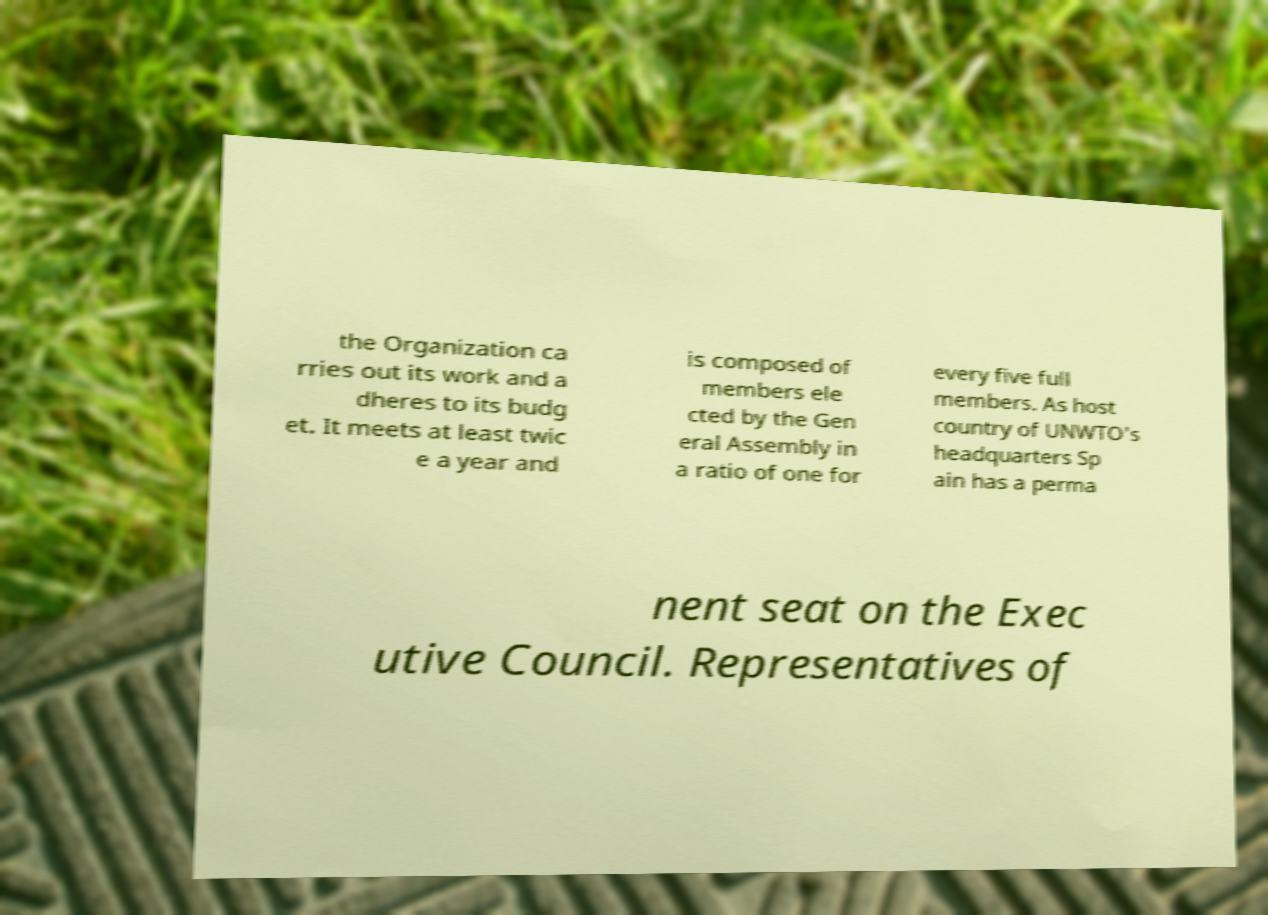I need the written content from this picture converted into text. Can you do that? the Organization ca rries out its work and a dheres to its budg et. It meets at least twic e a year and is composed of members ele cted by the Gen eral Assembly in a ratio of one for every five full members. As host country of UNWTO's headquarters Sp ain has a perma nent seat on the Exec utive Council. Representatives of 